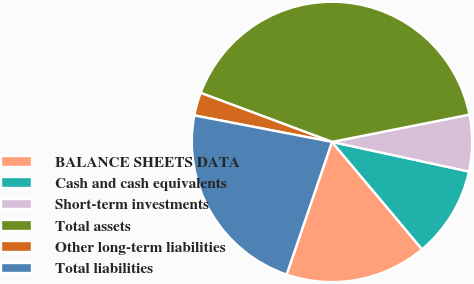Convert chart to OTSL. <chart><loc_0><loc_0><loc_500><loc_500><pie_chart><fcel>BALANCE SHEETS DATA<fcel>Cash and cash equivalents<fcel>Short-term investments<fcel>Total assets<fcel>Other long-term liabilities<fcel>Total liabilities<nl><fcel>16.36%<fcel>10.5%<fcel>6.51%<fcel>41.2%<fcel>2.66%<fcel>22.78%<nl></chart> 